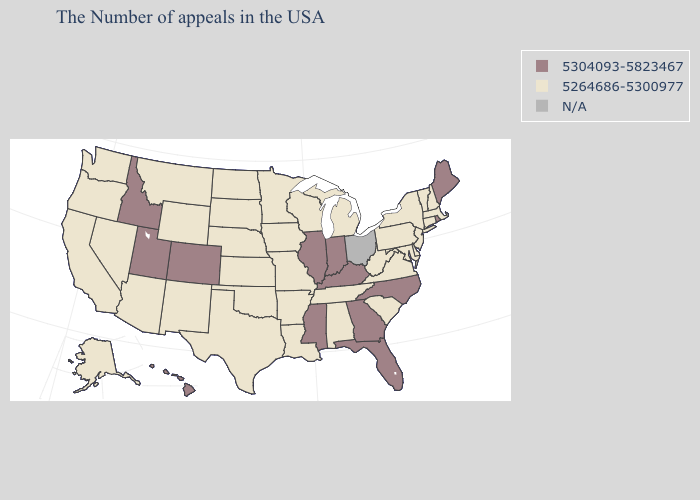Name the states that have a value in the range 5264686-5300977?
Short answer required. Massachusetts, New Hampshire, Vermont, Connecticut, New York, New Jersey, Delaware, Maryland, Pennsylvania, Virginia, South Carolina, West Virginia, Michigan, Alabama, Tennessee, Wisconsin, Louisiana, Missouri, Arkansas, Minnesota, Iowa, Kansas, Nebraska, Oklahoma, Texas, South Dakota, North Dakota, Wyoming, New Mexico, Montana, Arizona, Nevada, California, Washington, Oregon, Alaska. Name the states that have a value in the range 5264686-5300977?
Keep it brief. Massachusetts, New Hampshire, Vermont, Connecticut, New York, New Jersey, Delaware, Maryland, Pennsylvania, Virginia, South Carolina, West Virginia, Michigan, Alabama, Tennessee, Wisconsin, Louisiana, Missouri, Arkansas, Minnesota, Iowa, Kansas, Nebraska, Oklahoma, Texas, South Dakota, North Dakota, Wyoming, New Mexico, Montana, Arizona, Nevada, California, Washington, Oregon, Alaska. Name the states that have a value in the range 5264686-5300977?
Quick response, please. Massachusetts, New Hampshire, Vermont, Connecticut, New York, New Jersey, Delaware, Maryland, Pennsylvania, Virginia, South Carolina, West Virginia, Michigan, Alabama, Tennessee, Wisconsin, Louisiana, Missouri, Arkansas, Minnesota, Iowa, Kansas, Nebraska, Oklahoma, Texas, South Dakota, North Dakota, Wyoming, New Mexico, Montana, Arizona, Nevada, California, Washington, Oregon, Alaska. Name the states that have a value in the range 5264686-5300977?
Short answer required. Massachusetts, New Hampshire, Vermont, Connecticut, New York, New Jersey, Delaware, Maryland, Pennsylvania, Virginia, South Carolina, West Virginia, Michigan, Alabama, Tennessee, Wisconsin, Louisiana, Missouri, Arkansas, Minnesota, Iowa, Kansas, Nebraska, Oklahoma, Texas, South Dakota, North Dakota, Wyoming, New Mexico, Montana, Arizona, Nevada, California, Washington, Oregon, Alaska. Does the map have missing data?
Short answer required. Yes. What is the highest value in the USA?
Keep it brief. 5304093-5823467. What is the value of Alabama?
Quick response, please. 5264686-5300977. Name the states that have a value in the range N/A?
Short answer required. Ohio. What is the lowest value in states that border Rhode Island?
Write a very short answer. 5264686-5300977. Among the states that border Vermont , which have the lowest value?
Concise answer only. Massachusetts, New Hampshire, New York. How many symbols are there in the legend?
Give a very brief answer. 3. Name the states that have a value in the range N/A?
Keep it brief. Ohio. 